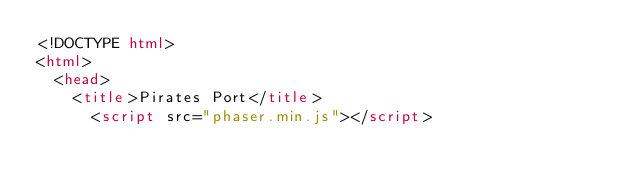Convert code to text. <code><loc_0><loc_0><loc_500><loc_500><_HTML_><!DOCTYPE html>
<html>
  <head>
    <title>Pirates Port</title>
      <script src="phaser.min.js"></script></code> 